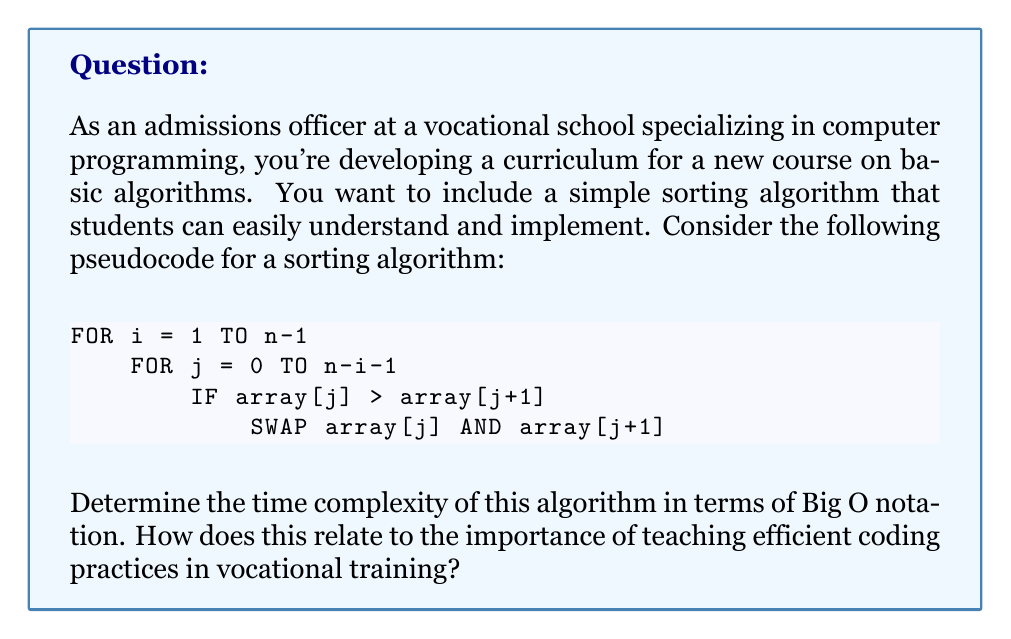Help me with this question. To determine the time complexity of this algorithm, we need to analyze the number of operations performed relative to the input size $n$. Let's break it down step-by-step:

1. The outer loop runs from $1$ to $n-1$, which is $(n-1)$ times.

2. For each iteration of the outer loop, the inner loop runs from $0$ to $n-i-1$:
   - When $i = 1$, the inner loop runs $n-1$ times
   - When $i = 2$, the inner loop runs $n-2$ times
   - ...
   - When $i = n-1$, the inner loop runs $1$ time

3. The total number of comparisons (and potential swaps) is the sum of these iterations:
   $$(n-1) + (n-2) + (n-3) + ... + 2 + 1$$

4. This sum is an arithmetic sequence with $(n-1)$ terms. The sum of an arithmetic sequence is given by:
   $$S = \frac{n(a_1 + a_n)}{2}$$
   where $n$ is the number of terms, $a_1$ is the first term, and $a_n$ is the last term.

5. In our case:
   $n = n-1$ (number of terms)
   $a_1 = n-1$ (first term)
   $a_n = 1$ (last term)

6. Plugging these into the formula:
   $$S = \frac{(n-1)((n-1) + 1)}{2} = \frac{(n-1)n}{2} = \frac{n^2 - n}{2}$$

7. In Big O notation, we only care about the highest order term and drop constants. Therefore, the time complexity is $O(n^2)$.

This quadratic time complexity demonstrates that for large inputs, the algorithm becomes significantly slower. In vocational training, it's crucial to teach students about algorithm efficiency as it directly impacts the performance of software in real-world applications. Understanding time complexity helps students make informed decisions about algorithm choice and optimization, which are valuable skills in the job market.
Answer: The time complexity of the given sorting algorithm is $O(n^2)$. 